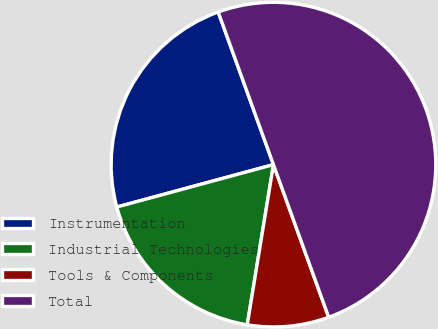Convert chart. <chart><loc_0><loc_0><loc_500><loc_500><pie_chart><fcel>Instrumentation<fcel>Industrial Technologies<fcel>Tools & Components<fcel>Total<nl><fcel>23.68%<fcel>18.21%<fcel>8.11%<fcel>50.0%<nl></chart> 